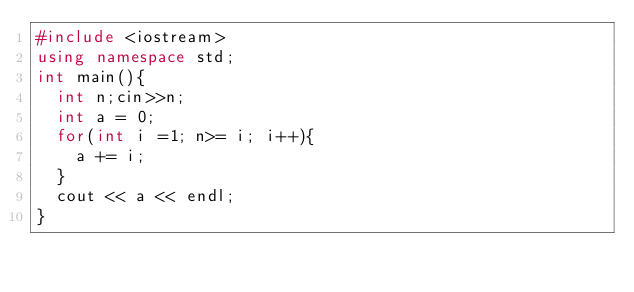<code> <loc_0><loc_0><loc_500><loc_500><_C++_>#include <iostream>
using namespace std;
int main(){
  int n;cin>>n;
  int a = 0;
  for(int i =1; n>= i; i++){
    a += i;
  }
  cout << a << endl;
}</code> 